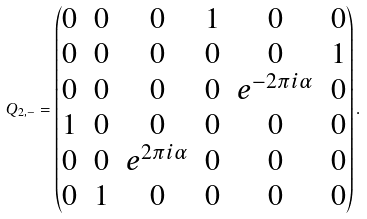Convert formula to latex. <formula><loc_0><loc_0><loc_500><loc_500>Q _ { 2 , - } = \begin{pmatrix} 0 & 0 & 0 & 1 & 0 & 0 \\ 0 & 0 & 0 & 0 & 0 & 1 \\ 0 & 0 & 0 & 0 & e ^ { - 2 \pi i \alpha } & 0 \\ 1 & 0 & 0 & 0 & 0 & 0 \\ 0 & 0 & e ^ { 2 \pi i \alpha } & 0 & 0 & 0 \\ 0 & 1 & 0 & 0 & 0 & 0 \end{pmatrix} .</formula> 